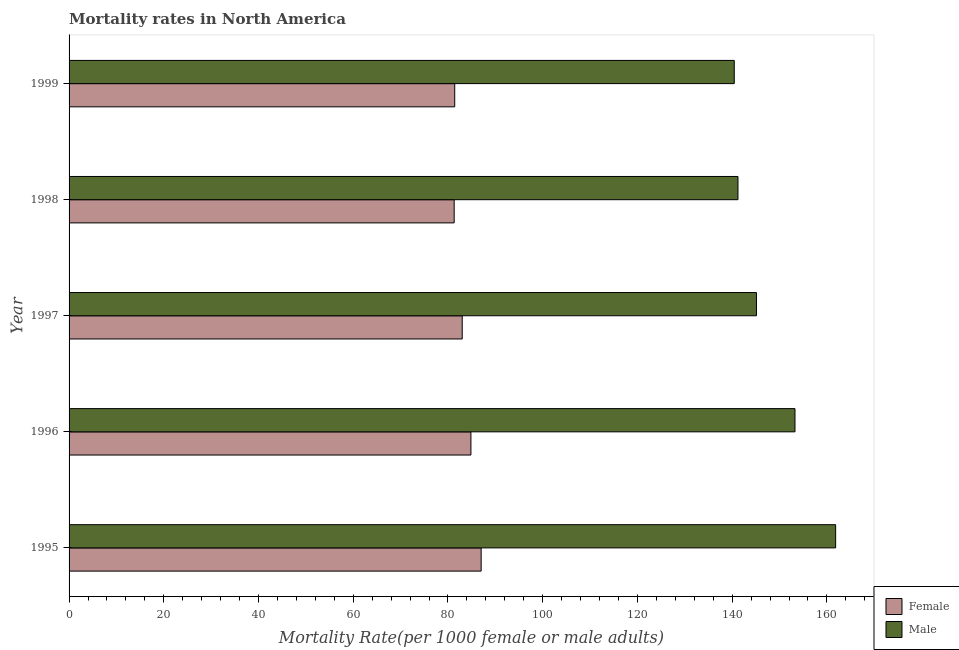How many different coloured bars are there?
Make the answer very short. 2. How many groups of bars are there?
Your response must be concise. 5. Are the number of bars per tick equal to the number of legend labels?
Ensure brevity in your answer.  Yes. Are the number of bars on each tick of the Y-axis equal?
Your answer should be compact. Yes. How many bars are there on the 3rd tick from the bottom?
Your answer should be very brief. 2. What is the label of the 1st group of bars from the top?
Your response must be concise. 1999. In how many cases, is the number of bars for a given year not equal to the number of legend labels?
Make the answer very short. 0. What is the male mortality rate in 1997?
Provide a succinct answer. 145.13. Across all years, what is the maximum female mortality rate?
Offer a very short reply. 87. Across all years, what is the minimum male mortality rate?
Keep it short and to the point. 140.44. In which year was the male mortality rate maximum?
Make the answer very short. 1995. What is the total female mortality rate in the graph?
Your answer should be very brief. 417.58. What is the difference between the male mortality rate in 1998 and that in 1999?
Give a very brief answer. 0.78. What is the difference between the male mortality rate in 1995 and the female mortality rate in 1997?
Your response must be concise. 78.84. What is the average male mortality rate per year?
Ensure brevity in your answer.  148.38. In the year 1997, what is the difference between the female mortality rate and male mortality rate?
Provide a succinct answer. -62.12. In how many years, is the male mortality rate greater than 68 ?
Ensure brevity in your answer.  5. What is the ratio of the male mortality rate in 1996 to that in 1998?
Provide a succinct answer. 1.08. Is the male mortality rate in 1997 less than that in 1999?
Provide a short and direct response. No. Is the difference between the female mortality rate in 1996 and 1998 greater than the difference between the male mortality rate in 1996 and 1998?
Ensure brevity in your answer.  No. What is the difference between the highest and the second highest female mortality rate?
Your answer should be compact. 2.16. What is the difference between the highest and the lowest male mortality rate?
Ensure brevity in your answer.  21.4. What does the 1st bar from the bottom in 1996 represents?
Ensure brevity in your answer.  Female. What is the difference between two consecutive major ticks on the X-axis?
Ensure brevity in your answer.  20. Are the values on the major ticks of X-axis written in scientific E-notation?
Keep it short and to the point. No. How many legend labels are there?
Offer a terse response. 2. What is the title of the graph?
Your answer should be compact. Mortality rates in North America. Does "Female labourers" appear as one of the legend labels in the graph?
Offer a very short reply. No. What is the label or title of the X-axis?
Provide a succinct answer. Mortality Rate(per 1000 female or male adults). What is the label or title of the Y-axis?
Make the answer very short. Year. What is the Mortality Rate(per 1000 female or male adults) in Female in 1995?
Offer a terse response. 87. What is the Mortality Rate(per 1000 female or male adults) of Male in 1995?
Your response must be concise. 161.85. What is the Mortality Rate(per 1000 female or male adults) of Female in 1996?
Provide a short and direct response. 84.84. What is the Mortality Rate(per 1000 female or male adults) in Male in 1996?
Give a very brief answer. 153.26. What is the Mortality Rate(per 1000 female or male adults) in Female in 1997?
Ensure brevity in your answer.  83. What is the Mortality Rate(per 1000 female or male adults) in Male in 1997?
Your answer should be compact. 145.13. What is the Mortality Rate(per 1000 female or male adults) of Female in 1998?
Make the answer very short. 81.31. What is the Mortality Rate(per 1000 female or male adults) of Male in 1998?
Your response must be concise. 141.22. What is the Mortality Rate(per 1000 female or male adults) in Female in 1999?
Offer a terse response. 81.42. What is the Mortality Rate(per 1000 female or male adults) in Male in 1999?
Your response must be concise. 140.44. Across all years, what is the maximum Mortality Rate(per 1000 female or male adults) in Female?
Your response must be concise. 87. Across all years, what is the maximum Mortality Rate(per 1000 female or male adults) of Male?
Provide a succinct answer. 161.85. Across all years, what is the minimum Mortality Rate(per 1000 female or male adults) of Female?
Provide a short and direct response. 81.31. Across all years, what is the minimum Mortality Rate(per 1000 female or male adults) in Male?
Provide a succinct answer. 140.44. What is the total Mortality Rate(per 1000 female or male adults) in Female in the graph?
Give a very brief answer. 417.58. What is the total Mortality Rate(per 1000 female or male adults) of Male in the graph?
Your answer should be very brief. 741.9. What is the difference between the Mortality Rate(per 1000 female or male adults) of Female in 1995 and that in 1996?
Give a very brief answer. 2.16. What is the difference between the Mortality Rate(per 1000 female or male adults) of Male in 1995 and that in 1996?
Your response must be concise. 8.59. What is the difference between the Mortality Rate(per 1000 female or male adults) in Female in 1995 and that in 1997?
Make the answer very short. 4. What is the difference between the Mortality Rate(per 1000 female or male adults) in Male in 1995 and that in 1997?
Provide a short and direct response. 16.72. What is the difference between the Mortality Rate(per 1000 female or male adults) in Female in 1995 and that in 1998?
Give a very brief answer. 5.7. What is the difference between the Mortality Rate(per 1000 female or male adults) of Male in 1995 and that in 1998?
Keep it short and to the point. 20.62. What is the difference between the Mortality Rate(per 1000 female or male adults) of Female in 1995 and that in 1999?
Your answer should be very brief. 5.58. What is the difference between the Mortality Rate(per 1000 female or male adults) of Male in 1995 and that in 1999?
Give a very brief answer. 21.4. What is the difference between the Mortality Rate(per 1000 female or male adults) in Female in 1996 and that in 1997?
Offer a terse response. 1.84. What is the difference between the Mortality Rate(per 1000 female or male adults) in Male in 1996 and that in 1997?
Ensure brevity in your answer.  8.14. What is the difference between the Mortality Rate(per 1000 female or male adults) in Female in 1996 and that in 1998?
Provide a succinct answer. 3.54. What is the difference between the Mortality Rate(per 1000 female or male adults) of Male in 1996 and that in 1998?
Make the answer very short. 12.04. What is the difference between the Mortality Rate(per 1000 female or male adults) in Female in 1996 and that in 1999?
Make the answer very short. 3.42. What is the difference between the Mortality Rate(per 1000 female or male adults) in Male in 1996 and that in 1999?
Provide a short and direct response. 12.82. What is the difference between the Mortality Rate(per 1000 female or male adults) in Female in 1997 and that in 1998?
Provide a succinct answer. 1.7. What is the difference between the Mortality Rate(per 1000 female or male adults) of Male in 1997 and that in 1998?
Your answer should be very brief. 3.9. What is the difference between the Mortality Rate(per 1000 female or male adults) in Female in 1997 and that in 1999?
Your response must be concise. 1.58. What is the difference between the Mortality Rate(per 1000 female or male adults) of Male in 1997 and that in 1999?
Ensure brevity in your answer.  4.68. What is the difference between the Mortality Rate(per 1000 female or male adults) in Female in 1998 and that in 1999?
Ensure brevity in your answer.  -0.12. What is the difference between the Mortality Rate(per 1000 female or male adults) in Male in 1998 and that in 1999?
Give a very brief answer. 0.78. What is the difference between the Mortality Rate(per 1000 female or male adults) of Female in 1995 and the Mortality Rate(per 1000 female or male adults) of Male in 1996?
Your response must be concise. -66.26. What is the difference between the Mortality Rate(per 1000 female or male adults) in Female in 1995 and the Mortality Rate(per 1000 female or male adults) in Male in 1997?
Your response must be concise. -58.12. What is the difference between the Mortality Rate(per 1000 female or male adults) of Female in 1995 and the Mortality Rate(per 1000 female or male adults) of Male in 1998?
Your answer should be very brief. -54.22. What is the difference between the Mortality Rate(per 1000 female or male adults) of Female in 1995 and the Mortality Rate(per 1000 female or male adults) of Male in 1999?
Provide a succinct answer. -53.44. What is the difference between the Mortality Rate(per 1000 female or male adults) in Female in 1996 and the Mortality Rate(per 1000 female or male adults) in Male in 1997?
Your answer should be very brief. -60.28. What is the difference between the Mortality Rate(per 1000 female or male adults) in Female in 1996 and the Mortality Rate(per 1000 female or male adults) in Male in 1998?
Offer a very short reply. -56.38. What is the difference between the Mortality Rate(per 1000 female or male adults) of Female in 1996 and the Mortality Rate(per 1000 female or male adults) of Male in 1999?
Provide a short and direct response. -55.6. What is the difference between the Mortality Rate(per 1000 female or male adults) in Female in 1997 and the Mortality Rate(per 1000 female or male adults) in Male in 1998?
Provide a succinct answer. -58.22. What is the difference between the Mortality Rate(per 1000 female or male adults) in Female in 1997 and the Mortality Rate(per 1000 female or male adults) in Male in 1999?
Provide a succinct answer. -57.44. What is the difference between the Mortality Rate(per 1000 female or male adults) in Female in 1998 and the Mortality Rate(per 1000 female or male adults) in Male in 1999?
Offer a very short reply. -59.14. What is the average Mortality Rate(per 1000 female or male adults) of Female per year?
Make the answer very short. 83.52. What is the average Mortality Rate(per 1000 female or male adults) of Male per year?
Provide a succinct answer. 148.38. In the year 1995, what is the difference between the Mortality Rate(per 1000 female or male adults) of Female and Mortality Rate(per 1000 female or male adults) of Male?
Keep it short and to the point. -74.84. In the year 1996, what is the difference between the Mortality Rate(per 1000 female or male adults) of Female and Mortality Rate(per 1000 female or male adults) of Male?
Provide a short and direct response. -68.42. In the year 1997, what is the difference between the Mortality Rate(per 1000 female or male adults) in Female and Mortality Rate(per 1000 female or male adults) in Male?
Your answer should be very brief. -62.12. In the year 1998, what is the difference between the Mortality Rate(per 1000 female or male adults) of Female and Mortality Rate(per 1000 female or male adults) of Male?
Give a very brief answer. -59.92. In the year 1999, what is the difference between the Mortality Rate(per 1000 female or male adults) of Female and Mortality Rate(per 1000 female or male adults) of Male?
Give a very brief answer. -59.02. What is the ratio of the Mortality Rate(per 1000 female or male adults) of Female in 1995 to that in 1996?
Your answer should be very brief. 1.03. What is the ratio of the Mortality Rate(per 1000 female or male adults) in Male in 1995 to that in 1996?
Ensure brevity in your answer.  1.06. What is the ratio of the Mortality Rate(per 1000 female or male adults) of Female in 1995 to that in 1997?
Provide a succinct answer. 1.05. What is the ratio of the Mortality Rate(per 1000 female or male adults) of Male in 1995 to that in 1997?
Give a very brief answer. 1.12. What is the ratio of the Mortality Rate(per 1000 female or male adults) in Female in 1995 to that in 1998?
Offer a terse response. 1.07. What is the ratio of the Mortality Rate(per 1000 female or male adults) in Male in 1995 to that in 1998?
Give a very brief answer. 1.15. What is the ratio of the Mortality Rate(per 1000 female or male adults) in Female in 1995 to that in 1999?
Offer a terse response. 1.07. What is the ratio of the Mortality Rate(per 1000 female or male adults) in Male in 1995 to that in 1999?
Your answer should be very brief. 1.15. What is the ratio of the Mortality Rate(per 1000 female or male adults) of Female in 1996 to that in 1997?
Give a very brief answer. 1.02. What is the ratio of the Mortality Rate(per 1000 female or male adults) in Male in 1996 to that in 1997?
Make the answer very short. 1.06. What is the ratio of the Mortality Rate(per 1000 female or male adults) in Female in 1996 to that in 1998?
Offer a very short reply. 1.04. What is the ratio of the Mortality Rate(per 1000 female or male adults) in Male in 1996 to that in 1998?
Offer a terse response. 1.09. What is the ratio of the Mortality Rate(per 1000 female or male adults) in Female in 1996 to that in 1999?
Make the answer very short. 1.04. What is the ratio of the Mortality Rate(per 1000 female or male adults) of Male in 1996 to that in 1999?
Provide a short and direct response. 1.09. What is the ratio of the Mortality Rate(per 1000 female or male adults) of Female in 1997 to that in 1998?
Offer a very short reply. 1.02. What is the ratio of the Mortality Rate(per 1000 female or male adults) in Male in 1997 to that in 1998?
Offer a terse response. 1.03. What is the ratio of the Mortality Rate(per 1000 female or male adults) of Female in 1997 to that in 1999?
Provide a short and direct response. 1.02. What is the ratio of the Mortality Rate(per 1000 female or male adults) of Female in 1998 to that in 1999?
Your answer should be very brief. 1. What is the difference between the highest and the second highest Mortality Rate(per 1000 female or male adults) of Female?
Give a very brief answer. 2.16. What is the difference between the highest and the second highest Mortality Rate(per 1000 female or male adults) in Male?
Offer a terse response. 8.59. What is the difference between the highest and the lowest Mortality Rate(per 1000 female or male adults) in Female?
Ensure brevity in your answer.  5.7. What is the difference between the highest and the lowest Mortality Rate(per 1000 female or male adults) of Male?
Keep it short and to the point. 21.4. 